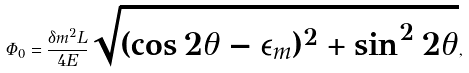<formula> <loc_0><loc_0><loc_500><loc_500>\Phi _ { 0 } = \frac { \delta m ^ { 2 } L } { 4 E } \sqrt { ( \cos 2 \theta - \epsilon _ { m } ) ^ { 2 } + \sin ^ { 2 } 2 \theta } ,</formula> 